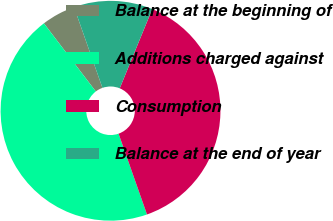Convert chart. <chart><loc_0><loc_0><loc_500><loc_500><pie_chart><fcel>Balance at the beginning of<fcel>Additions charged against<fcel>Consumption<fcel>Balance at the end of year<nl><fcel>4.98%<fcel>45.02%<fcel>38.42%<fcel>11.58%<nl></chart> 